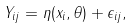Convert formula to latex. <formula><loc_0><loc_0><loc_500><loc_500>Y _ { i j } = \eta ( x _ { i } , \theta ) + \epsilon _ { i j } ,</formula> 